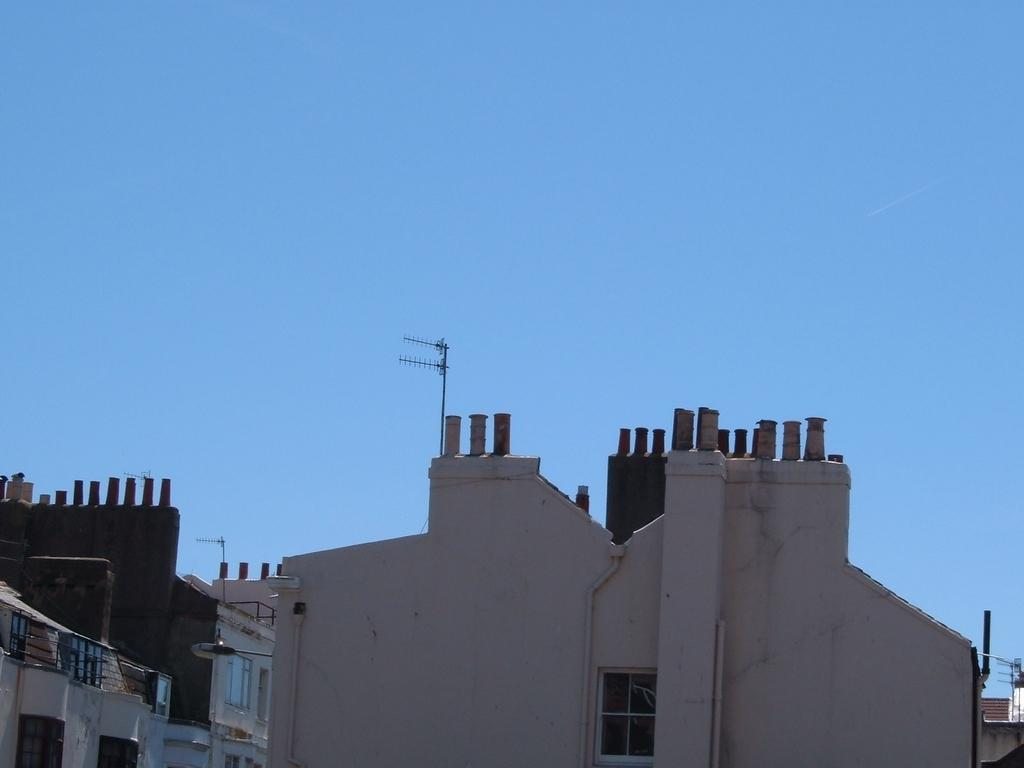What is the main subject in the center of the image? There are buildings in the center of the image. What can be seen at the top of the image? The sky is visible at the top of the image. Where is the meeting taking place in the image? There is no meeting present in the image; it only features buildings and the sky. 